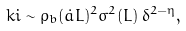Convert formula to latex. <formula><loc_0><loc_0><loc_500><loc_500>\ k i \sim \varrho _ { b } ( \dot { a } L ) ^ { 2 } \sigma ^ { 2 } ( L ) \, \delta ^ { 2 - \eta } ,</formula> 